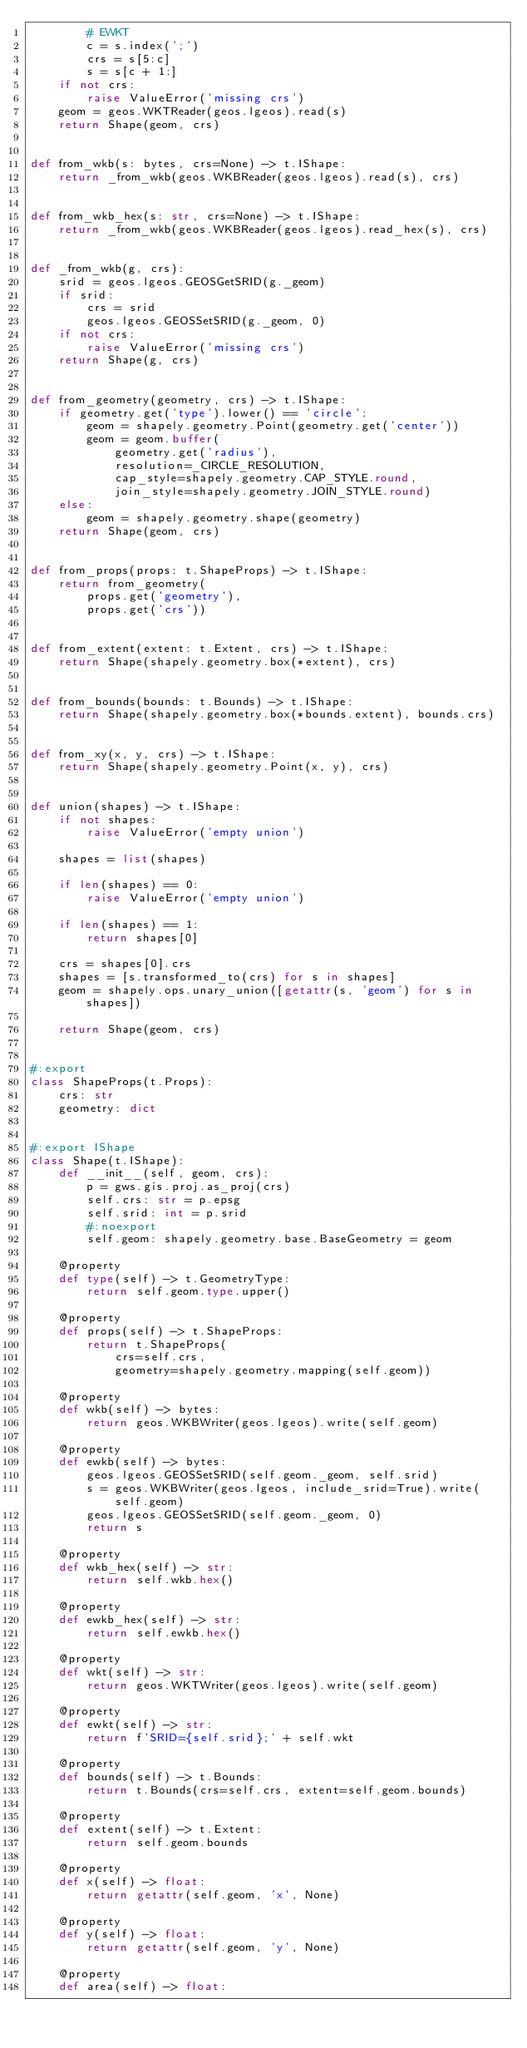Convert code to text. <code><loc_0><loc_0><loc_500><loc_500><_Python_>        # EWKT
        c = s.index(';')
        crs = s[5:c]
        s = s[c + 1:]
    if not crs:
        raise ValueError('missing crs')
    geom = geos.WKTReader(geos.lgeos).read(s)
    return Shape(geom, crs)


def from_wkb(s: bytes, crs=None) -> t.IShape:
    return _from_wkb(geos.WKBReader(geos.lgeos).read(s), crs)


def from_wkb_hex(s: str, crs=None) -> t.IShape:
    return _from_wkb(geos.WKBReader(geos.lgeos).read_hex(s), crs)


def _from_wkb(g, crs):
    srid = geos.lgeos.GEOSGetSRID(g._geom)
    if srid:
        crs = srid
        geos.lgeos.GEOSSetSRID(g._geom, 0)
    if not crs:
        raise ValueError('missing crs')
    return Shape(g, crs)


def from_geometry(geometry, crs) -> t.IShape:
    if geometry.get('type').lower() == 'circle':
        geom = shapely.geometry.Point(geometry.get('center'))
        geom = geom.buffer(
            geometry.get('radius'),
            resolution=_CIRCLE_RESOLUTION,
            cap_style=shapely.geometry.CAP_STYLE.round,
            join_style=shapely.geometry.JOIN_STYLE.round)
    else:
        geom = shapely.geometry.shape(geometry)
    return Shape(geom, crs)


def from_props(props: t.ShapeProps) -> t.IShape:
    return from_geometry(
        props.get('geometry'),
        props.get('crs'))


def from_extent(extent: t.Extent, crs) -> t.IShape:
    return Shape(shapely.geometry.box(*extent), crs)


def from_bounds(bounds: t.Bounds) -> t.IShape:
    return Shape(shapely.geometry.box(*bounds.extent), bounds.crs)


def from_xy(x, y, crs) -> t.IShape:
    return Shape(shapely.geometry.Point(x, y), crs)


def union(shapes) -> t.IShape:
    if not shapes:
        raise ValueError('empty union')

    shapes = list(shapes)

    if len(shapes) == 0:
        raise ValueError('empty union')

    if len(shapes) == 1:
        return shapes[0]

    crs = shapes[0].crs
    shapes = [s.transformed_to(crs) for s in shapes]
    geom = shapely.ops.unary_union([getattr(s, 'geom') for s in shapes])

    return Shape(geom, crs)


#:export
class ShapeProps(t.Props):
    crs: str
    geometry: dict


#:export IShape
class Shape(t.IShape):
    def __init__(self, geom, crs):
        p = gws.gis.proj.as_proj(crs)
        self.crs: str = p.epsg
        self.srid: int = p.srid
        #:noexport
        self.geom: shapely.geometry.base.BaseGeometry = geom

    @property
    def type(self) -> t.GeometryType:
        return self.geom.type.upper()

    @property
    def props(self) -> t.ShapeProps:
        return t.ShapeProps(
            crs=self.crs,
            geometry=shapely.geometry.mapping(self.geom))

    @property
    def wkb(self) -> bytes:
        return geos.WKBWriter(geos.lgeos).write(self.geom)

    @property
    def ewkb(self) -> bytes:
        geos.lgeos.GEOSSetSRID(self.geom._geom, self.srid)
        s = geos.WKBWriter(geos.lgeos, include_srid=True).write(self.geom)
        geos.lgeos.GEOSSetSRID(self.geom._geom, 0)
        return s

    @property
    def wkb_hex(self) -> str:
        return self.wkb.hex()

    @property
    def ewkb_hex(self) -> str:
        return self.ewkb.hex()

    @property
    def wkt(self) -> str:
        return geos.WKTWriter(geos.lgeos).write(self.geom)

    @property
    def ewkt(self) -> str:
        return f'SRID={self.srid};' + self.wkt

    @property
    def bounds(self) -> t.Bounds:
        return t.Bounds(crs=self.crs, extent=self.geom.bounds)

    @property
    def extent(self) -> t.Extent:
        return self.geom.bounds

    @property
    def x(self) -> float:
        return getattr(self.geom, 'x', None)

    @property
    def y(self) -> float:
        return getattr(self.geom, 'y', None)

    @property
    def area(self) -> float:</code> 